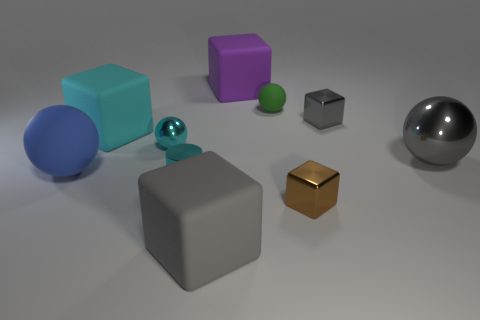There is a gray shiny thing that is in front of the tiny gray metallic object; what is its shape?
Your answer should be compact. Sphere. Are there the same number of gray shiny objects that are to the left of the large purple rubber thing and big cyan matte blocks that are to the right of the cyan metallic cylinder?
Offer a terse response. Yes. What number of things are either small shiny things or gray blocks on the right side of the green matte object?
Ensure brevity in your answer.  4. The tiny shiny thing that is in front of the cyan matte thing and right of the large purple rubber object has what shape?
Your answer should be very brief. Cube. There is a small ball on the right side of the small cyan thing in front of the big blue matte object; what is it made of?
Offer a terse response. Rubber. Do the large ball that is on the left side of the small cyan ball and the big cyan cube have the same material?
Ensure brevity in your answer.  Yes. There is a cyan metallic object on the left side of the tiny metal cylinder; what size is it?
Your answer should be very brief. Small. There is a small thing that is to the right of the tiny brown thing; are there any tiny green things that are in front of it?
Ensure brevity in your answer.  No. Is the color of the metal ball that is left of the large gray metallic object the same as the matte ball that is to the left of the green object?
Your answer should be compact. No. The shiny cylinder has what color?
Your response must be concise. Cyan. 